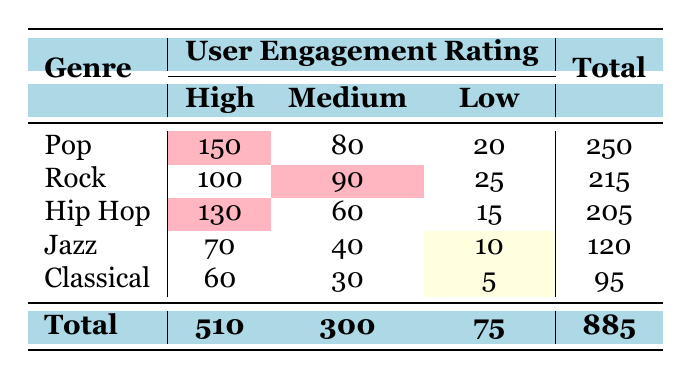What is the total number of users who rated Pop music? To find the total number of users who rated Pop music, we need to sum the counts of the engagement ratings for Pop: 150 (High) + 80 (Medium) + 20 (Low) = 250.
Answer: 250 Which genre received the lowest engagement rating for Low? Looking at the Low ratings across genres, Jazz has 10, Classical has 5, Rock has 25, Hip Hop has 15, and Pop has 20. The lowest count is for Classical, with a Low rating of 5.
Answer: Classical What is the average count for Medium engagement ratings across all genres? We sum the Medium ratings across all genres: 80 (Pop) + 90 (Rock) + 60 (Hip Hop) + 40 (Jazz) + 30 (Classical) = 300. There are 5 genres, so the average is 300/5 = 60.
Answer: 60 Is the total number of High engagement ratings greater than 400? The total count of High ratings is: 150 (Pop) + 100 (Rock) + 130 (Hip Hop) + 70 (Jazz) + 60 (Classical) = 510. Since 510 is greater than 400, the answer is yes.
Answer: Yes What percentage of users rated Hip Hop music as High? First, we find the number of users who rated Hip Hop as High, which is 130. The total number of users is 885. The percentage is calculated as (130/885) * 100, which equals approximately 14.68%.
Answer: 14.68% Which genre has the highest total number of user engagement ratings? We calculate the total count for each genre: Pop = 250, Rock = 215, Hip Hop = 205, Jazz = 120, and Classical = 95. The highest total is for Pop with 250 users.
Answer: Pop What is the difference in High ratings between Pop and Rock? The number of High ratings for Pop is 150 and for Rock is 100. The difference is calculated as 150 - 100 = 50.
Answer: 50 Did Jazz receive more Medium ratings than Classical? Jazz has 40 Medium ratings while Classical has 30 Medium ratings. Since 40 is greater than 30, the answer is yes.
Answer: Yes What is the total engagement across all genres for Low ratings? We sum up the Low ratings: 20 (Pop) + 25 (Rock) + 15 (Hip Hop) + 10 (Jazz) + 5 (Classical) = 75.
Answer: 75 